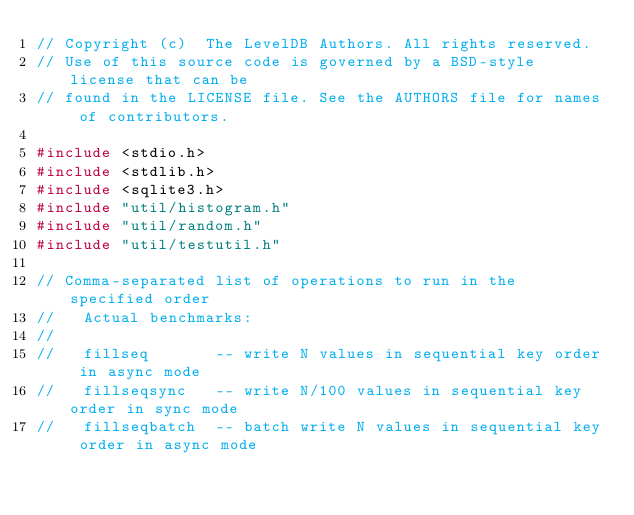<code> <loc_0><loc_0><loc_500><loc_500><_C++_>// Copyright (c)  The LevelDB Authors. All rights reserved.
// Use of this source code is governed by a BSD-style license that can be
// found in the LICENSE file. See the AUTHORS file for names of contributors.

#include <stdio.h>
#include <stdlib.h>
#include <sqlite3.h>
#include "util/histogram.h"
#include "util/random.h"
#include "util/testutil.h"

// Comma-separated list of operations to run in the specified order
//   Actual benchmarks:
//
//   fillseq       -- write N values in sequential key order in async mode
//   fillseqsync   -- write N/100 values in sequential key order in sync mode
//   fillseqbatch  -- batch write N values in sequential key order in async mode</code> 